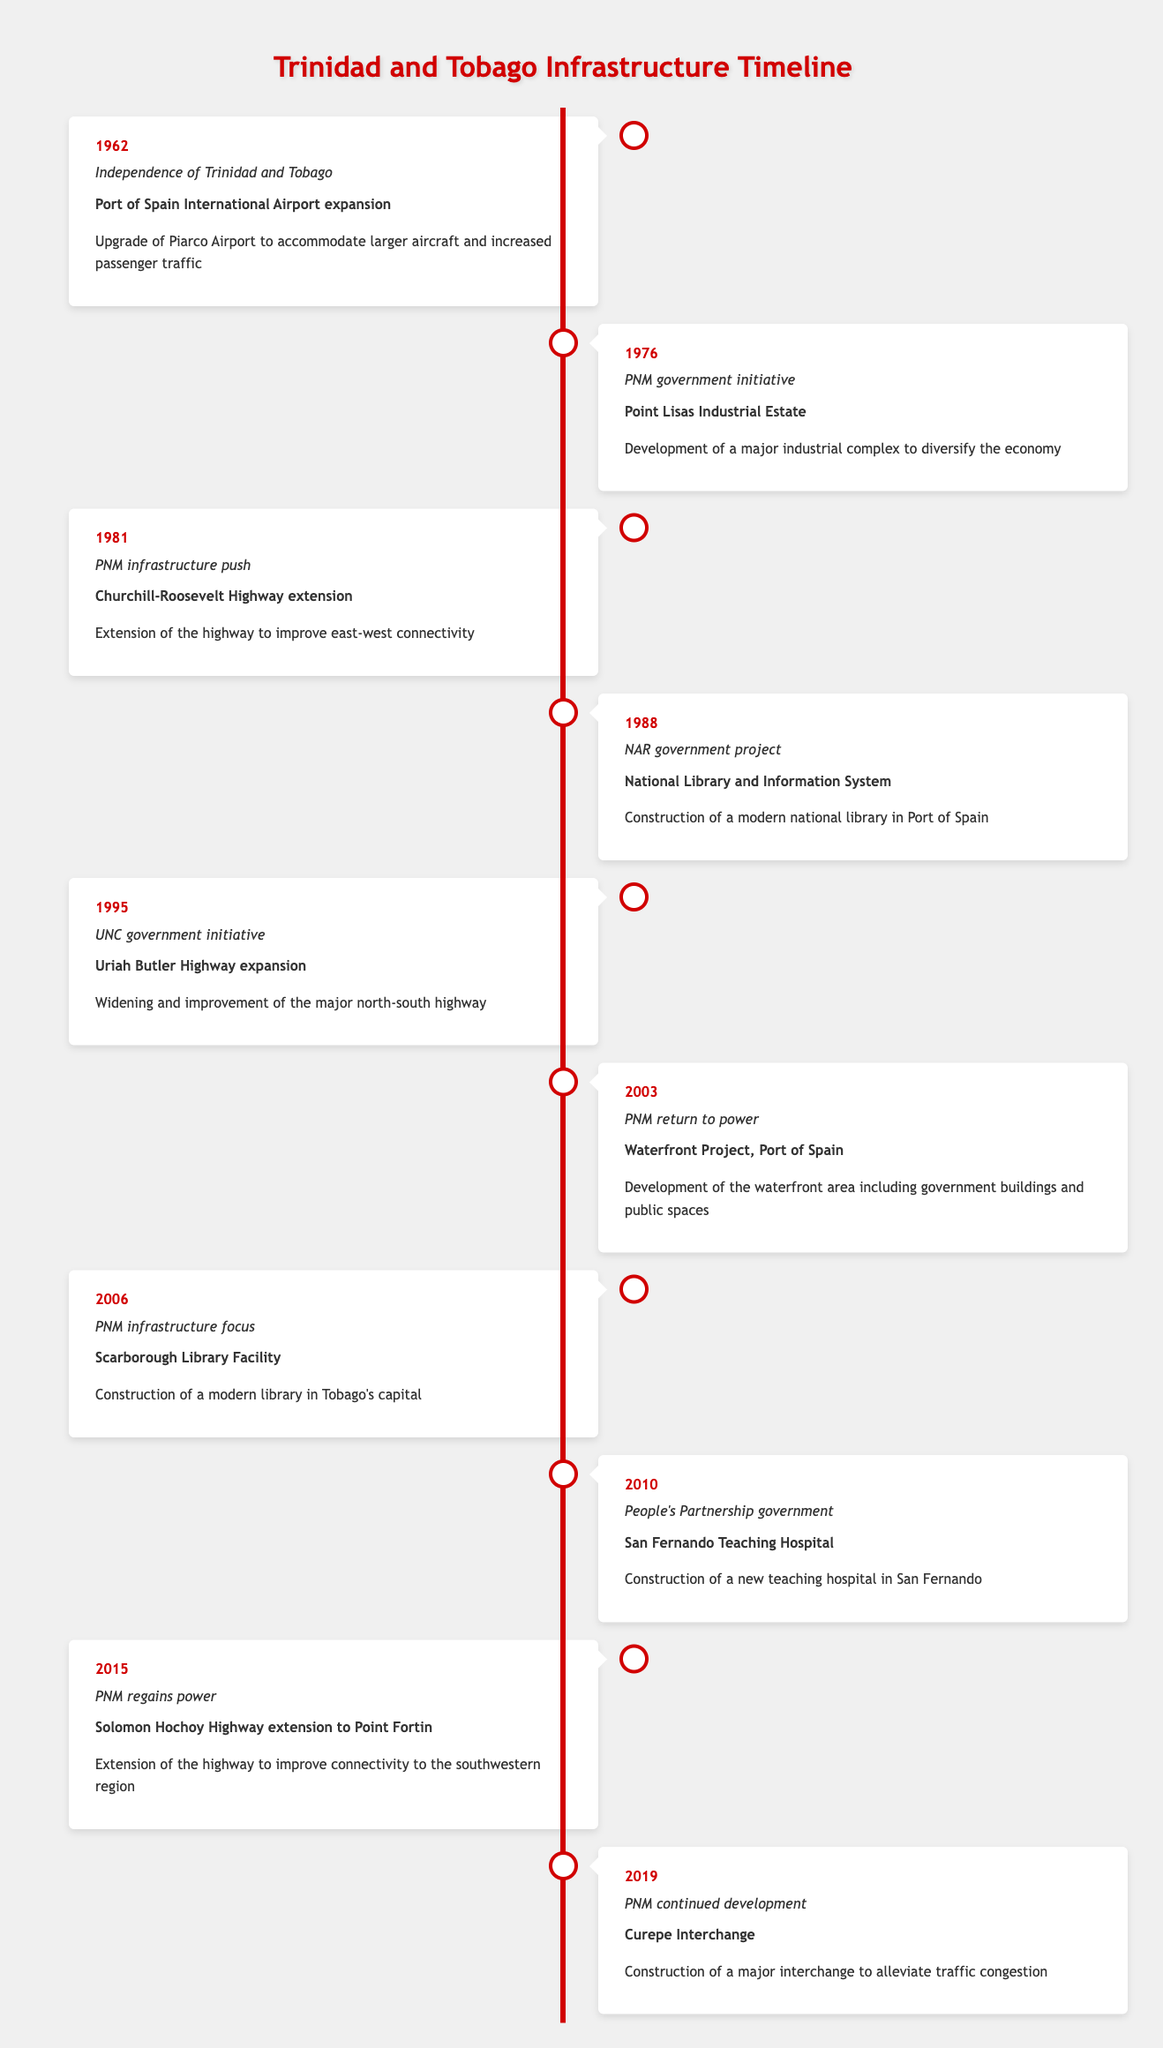What year did Trinidad and Tobago gain independence? The table indicates that the year of independence is listed in the first row, specifically under the "year" column for the event "Independence of Trinidad and Tobago." The corresponding year is 1962.
Answer: 1962 Which project was initiated by the PNM in 1976? Referring to the entry for the year 1976, the project associated with the PNM government initiative is listed as the "Point Lisas Industrial Estate."
Answer: Point Lisas Industrial Estate What is the total number of infrastructure projects mentioned in the timeline? To answer this, we need to count the number of entries in the table. There are a total of 10 distinct projects listed, each corresponding to a different event year.
Answer: 10 Was there any project concerning a library constructed after 2000? Looking at the entries after the year 2000, the "Scarborough Library Facility" was completed in 2006. This meets the criteria of being a library project after 2000.
Answer: Yes What was the significant infrastructure project that focused on east-west connectivity initiated by the PNM? In the table, for the year 1981, the project concerning east-west connectivity is "Churchill-Roosevelt Highway extension." This specifies a direct focus on improving the connectivity across the country.
Answer: Churchill-Roosevelt Highway extension How many years elapsed between the expansion of the Uriah Butler Highway and the Curepe Interchange construction? The Uriah Butler Highway expansion occurred in 1995, and the Curepe Interchange was constructed in 2019. The difference in years is 2019 - 1995 = 24 years.
Answer: 24 years Which project was described as a "People's Partnership government" initiative? The timeline indicates that the "San Fernando Teaching Hospital" construction is linked to the People's Partnership government, identified in the entry for the year 2010.
Answer: San Fernando Teaching Hospital Did any projects specifically mention improvements for traffic congestion? Yes, the "Curepe Interchange," built in 2019, is noted for its role in alleviating traffic congestion, as stated in its project description.
Answer: Yes Identify the infrastructure project that significantly begun in the year 2003 after PNM returned to power. According to the entry for 2003, the significant project mentioned is the "Waterfront Project, Port of Spain," indicating development efforts after PNM regained power.
Answer: Waterfront Project, Port of Spain 